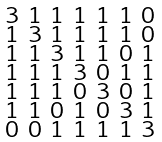Convert formula to latex. <formula><loc_0><loc_0><loc_500><loc_500>\begin{smallmatrix} 3 & 1 & 1 & 1 & 1 & 1 & 0 \\ 1 & 3 & 1 & 1 & 1 & 1 & 0 \\ 1 & 1 & 3 & 1 & 1 & 0 & 1 \\ 1 & 1 & 1 & 3 & 0 & 1 & 1 \\ 1 & 1 & 1 & 0 & 3 & 0 & 1 \\ 1 & 1 & 0 & 1 & 0 & 3 & 1 \\ 0 & 0 & 1 & 1 & 1 & 1 & 3 \end{smallmatrix}</formula> 